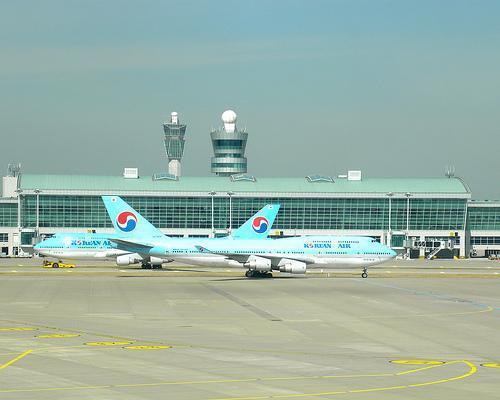How many planes are there?
Give a very brief answer. 2. 